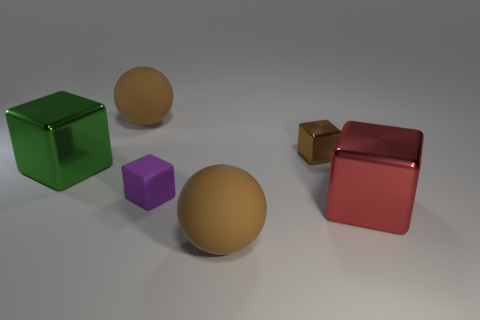Add 3 brown metal blocks. How many objects exist? 9 Subtract all metal cubes. How many cubes are left? 1 Subtract 1 spheres. How many spheres are left? 1 Subtract all purple cubes. How many cubes are left? 3 Subtract all brown blocks. Subtract all gray cylinders. How many blocks are left? 3 Subtract all brown shiny objects. Subtract all large balls. How many objects are left? 3 Add 6 big red objects. How many big red objects are left? 7 Add 6 tiny shiny things. How many tiny shiny things exist? 7 Subtract 0 green cylinders. How many objects are left? 6 Subtract all blocks. How many objects are left? 2 